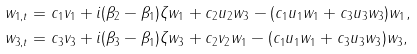<formula> <loc_0><loc_0><loc_500><loc_500>& w _ { 1 , t } = c _ { 1 } v _ { 1 } + i ( \beta _ { 2 } - \beta _ { 1 } ) \zeta w _ { 1 } + c _ { 2 } u _ { 2 } w _ { 3 } - ( c _ { 1 } u _ { 1 } w _ { 1 } + c _ { 3 } u _ { 3 } w _ { 3 } ) w _ { 1 } , \\ & w _ { 3 , t } = c _ { 3 } v _ { 3 } + i ( \beta _ { 3 } - \beta _ { 1 } ) \zeta w _ { 3 } + c _ { 2 } v _ { 2 } w _ { 1 } - ( c _ { 1 } u _ { 1 } w _ { 1 } + c _ { 3 } u _ { 3 } w _ { 3 } ) w _ { 3 } ,</formula> 